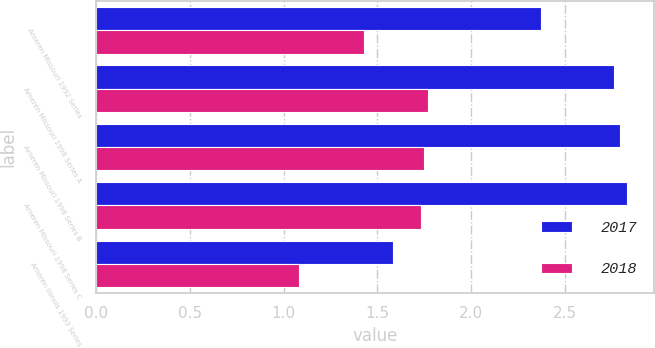Convert chart. <chart><loc_0><loc_0><loc_500><loc_500><stacked_bar_chart><ecel><fcel>Ameren Missouri 1992 Series<fcel>Ameren Missouri 1998 Series A<fcel>Ameren Missouri 1998 Series B<fcel>Ameren Missouri 1998 Series C<fcel>Ameren Illinois 1993 Series<nl><fcel>2017<fcel>2.37<fcel>2.76<fcel>2.79<fcel>2.83<fcel>1.58<nl><fcel>2018<fcel>1.43<fcel>1.77<fcel>1.75<fcel>1.73<fcel>1.08<nl></chart> 